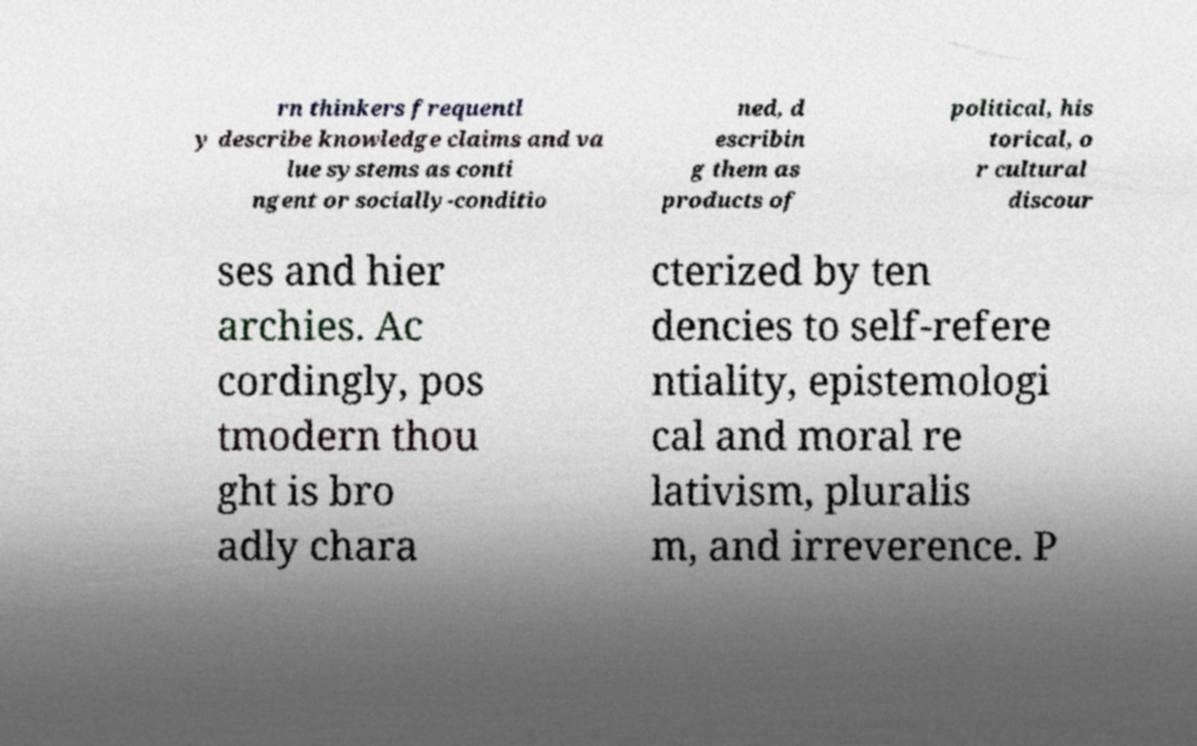Could you extract and type out the text from this image? rn thinkers frequentl y describe knowledge claims and va lue systems as conti ngent or socially-conditio ned, d escribin g them as products of political, his torical, o r cultural discour ses and hier archies. Ac cordingly, pos tmodern thou ght is bro adly chara cterized by ten dencies to self-refere ntiality, epistemologi cal and moral re lativism, pluralis m, and irreverence. P 